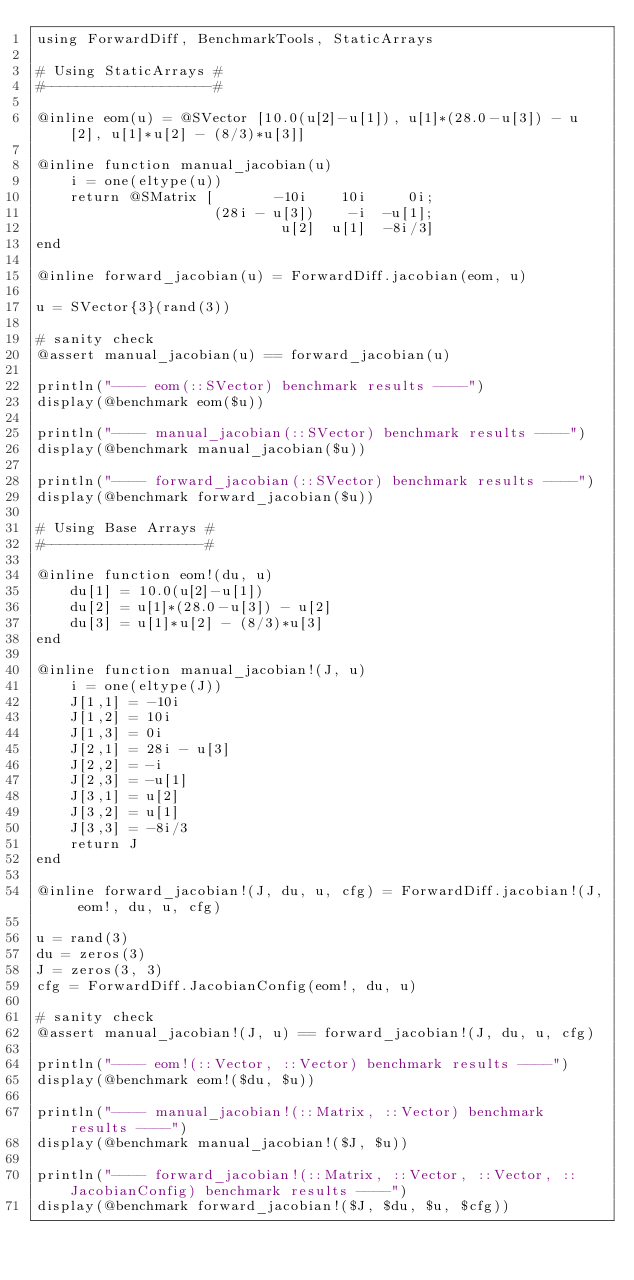<code> <loc_0><loc_0><loc_500><loc_500><_Julia_>using ForwardDiff, BenchmarkTools, StaticArrays

# Using StaticArrays #
#--------------------#

@inline eom(u) = @SVector [10.0(u[2]-u[1]), u[1]*(28.0-u[3]) - u[2], u[1]*u[2] - (8/3)*u[3]]

@inline function manual_jacobian(u)
    i = one(eltype(u))
    return @SMatrix [       -10i    10i     0i;
                     (28i - u[3])    -i  -u[1];
                             u[2]  u[1]  -8i/3]
end

@inline forward_jacobian(u) = ForwardDiff.jacobian(eom, u)

u = SVector{3}(rand(3))

# sanity check
@assert manual_jacobian(u) == forward_jacobian(u)

println("---- eom(::SVector) benchmark results ----")
display(@benchmark eom($u))

println("---- manual_jacobian(::SVector) benchmark results ----")
display(@benchmark manual_jacobian($u))

println("---- forward_jacobian(::SVector) benchmark results ----")
display(@benchmark forward_jacobian($u))

# Using Base Arrays #
#-------------------#

@inline function eom!(du, u)
    du[1] = 10.0(u[2]-u[1])
    du[2] = u[1]*(28.0-u[3]) - u[2]
    du[3] = u[1]*u[2] - (8/3)*u[3]
end

@inline function manual_jacobian!(J, u)
    i = one(eltype(J))
    J[1,1] = -10i
    J[1,2] = 10i
    J[1,3] = 0i
    J[2,1] = 28i - u[3]
    J[2,2] = -i
    J[2,3] = -u[1]
    J[3,1] = u[2]
    J[3,2] = u[1]
    J[3,3] = -8i/3
    return J
end

@inline forward_jacobian!(J, du, u, cfg) = ForwardDiff.jacobian!(J, eom!, du, u, cfg)

u = rand(3)
du = zeros(3)
J = zeros(3, 3)
cfg = ForwardDiff.JacobianConfig(eom!, du, u)

# sanity check
@assert manual_jacobian!(J, u) == forward_jacobian!(J, du, u, cfg)

println("---- eom!(::Vector, ::Vector) benchmark results ----")
display(@benchmark eom!($du, $u))

println("---- manual_jacobian!(::Matrix, ::Vector) benchmark results ----")
display(@benchmark manual_jacobian!($J, $u))

println("---- forward_jacobian!(::Matrix, ::Vector, ::Vector, ::JacobianConfig) benchmark results ----")
display(@benchmark forward_jacobian!($J, $du, $u, $cfg))
</code> 